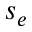Convert formula to latex. <formula><loc_0><loc_0><loc_500><loc_500>s _ { e }</formula> 